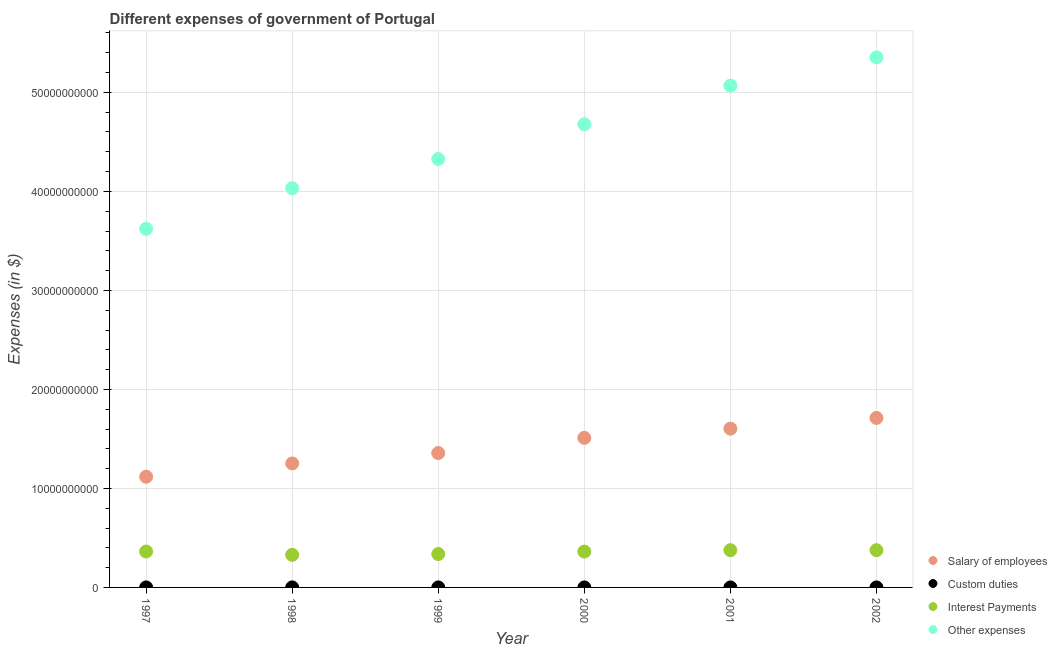What is the amount spent on other expenses in 2001?
Ensure brevity in your answer.  5.07e+1. Across all years, what is the maximum amount spent on salary of employees?
Your answer should be very brief. 1.71e+1. Across all years, what is the minimum amount spent on other expenses?
Make the answer very short. 3.62e+1. In which year was the amount spent on other expenses maximum?
Your answer should be very brief. 2002. In which year was the amount spent on interest payments minimum?
Offer a very short reply. 1998. What is the total amount spent on interest payments in the graph?
Provide a succinct answer. 2.14e+1. What is the difference between the amount spent on custom duties in 1997 and that in 2000?
Keep it short and to the point. 9.00e+05. What is the difference between the amount spent on other expenses in 1997 and the amount spent on custom duties in 1999?
Your answer should be very brief. 3.62e+1. What is the average amount spent on salary of employees per year?
Your answer should be very brief. 1.43e+1. In the year 2002, what is the difference between the amount spent on salary of employees and amount spent on interest payments?
Provide a succinct answer. 1.34e+1. What is the ratio of the amount spent on other expenses in 1998 to that in 2001?
Provide a succinct answer. 0.8. Is the amount spent on custom duties in 1997 less than that in 2001?
Provide a short and direct response. No. Is the difference between the amount spent on other expenses in 2001 and 2002 greater than the difference between the amount spent on interest payments in 2001 and 2002?
Your answer should be compact. No. What is the difference between the highest and the second highest amount spent on interest payments?
Your answer should be compact. 1.30e+06. What is the difference between the highest and the lowest amount spent on custom duties?
Give a very brief answer. 1.87e+06. Is the sum of the amount spent on custom duties in 1997 and 2002 greater than the maximum amount spent on interest payments across all years?
Provide a succinct answer. No. Is it the case that in every year, the sum of the amount spent on salary of employees and amount spent on custom duties is greater than the amount spent on interest payments?
Offer a terse response. Yes. Is the amount spent on salary of employees strictly less than the amount spent on custom duties over the years?
Give a very brief answer. No. How many dotlines are there?
Your answer should be very brief. 4. How many years are there in the graph?
Make the answer very short. 6. Are the values on the major ticks of Y-axis written in scientific E-notation?
Ensure brevity in your answer.  No. Where does the legend appear in the graph?
Give a very brief answer. Bottom right. How many legend labels are there?
Your answer should be compact. 4. What is the title of the graph?
Make the answer very short. Different expenses of government of Portugal. Does "Mammal species" appear as one of the legend labels in the graph?
Keep it short and to the point. No. What is the label or title of the Y-axis?
Keep it short and to the point. Expenses (in $). What is the Expenses (in $) in Salary of employees in 1997?
Give a very brief answer. 1.12e+1. What is the Expenses (in $) in Custom duties in 1997?
Make the answer very short. 1.55e+06. What is the Expenses (in $) in Interest Payments in 1997?
Make the answer very short. 3.63e+09. What is the Expenses (in $) of Other expenses in 1997?
Provide a succinct answer. 3.62e+1. What is the Expenses (in $) in Salary of employees in 1998?
Make the answer very short. 1.25e+1. What is the Expenses (in $) of Custom duties in 1998?
Your answer should be compact. 2.33e+06. What is the Expenses (in $) of Interest Payments in 1998?
Your response must be concise. 3.29e+09. What is the Expenses (in $) of Other expenses in 1998?
Your answer should be very brief. 4.03e+1. What is the Expenses (in $) of Salary of employees in 1999?
Offer a terse response. 1.36e+1. What is the Expenses (in $) in Custom duties in 1999?
Keep it short and to the point. 5.30e+05. What is the Expenses (in $) of Interest Payments in 1999?
Ensure brevity in your answer.  3.37e+09. What is the Expenses (in $) of Other expenses in 1999?
Ensure brevity in your answer.  4.33e+1. What is the Expenses (in $) in Salary of employees in 2000?
Your answer should be compact. 1.51e+1. What is the Expenses (in $) in Custom duties in 2000?
Offer a very short reply. 6.50e+05. What is the Expenses (in $) of Interest Payments in 2000?
Provide a succinct answer. 3.62e+09. What is the Expenses (in $) of Other expenses in 2000?
Ensure brevity in your answer.  4.68e+1. What is the Expenses (in $) of Salary of employees in 2001?
Ensure brevity in your answer.  1.60e+1. What is the Expenses (in $) in Custom duties in 2001?
Provide a succinct answer. 4.60e+05. What is the Expenses (in $) of Interest Payments in 2001?
Your answer should be very brief. 3.76e+09. What is the Expenses (in $) in Other expenses in 2001?
Keep it short and to the point. 5.07e+1. What is the Expenses (in $) in Salary of employees in 2002?
Your answer should be compact. 1.71e+1. What is the Expenses (in $) in Custom duties in 2002?
Make the answer very short. 5.10e+05. What is the Expenses (in $) in Interest Payments in 2002?
Your answer should be very brief. 3.76e+09. What is the Expenses (in $) of Other expenses in 2002?
Give a very brief answer. 5.35e+1. Across all years, what is the maximum Expenses (in $) in Salary of employees?
Your answer should be very brief. 1.71e+1. Across all years, what is the maximum Expenses (in $) in Custom duties?
Offer a very short reply. 2.33e+06. Across all years, what is the maximum Expenses (in $) in Interest Payments?
Offer a very short reply. 3.76e+09. Across all years, what is the maximum Expenses (in $) of Other expenses?
Provide a short and direct response. 5.35e+1. Across all years, what is the minimum Expenses (in $) of Salary of employees?
Give a very brief answer. 1.12e+1. Across all years, what is the minimum Expenses (in $) of Interest Payments?
Give a very brief answer. 3.29e+09. Across all years, what is the minimum Expenses (in $) in Other expenses?
Your answer should be very brief. 3.62e+1. What is the total Expenses (in $) of Salary of employees in the graph?
Your answer should be compact. 8.55e+1. What is the total Expenses (in $) of Custom duties in the graph?
Provide a short and direct response. 6.03e+06. What is the total Expenses (in $) in Interest Payments in the graph?
Your response must be concise. 2.14e+1. What is the total Expenses (in $) of Other expenses in the graph?
Your response must be concise. 2.71e+11. What is the difference between the Expenses (in $) in Salary of employees in 1997 and that in 1998?
Give a very brief answer. -1.34e+09. What is the difference between the Expenses (in $) of Custom duties in 1997 and that in 1998?
Provide a succinct answer. -7.80e+05. What is the difference between the Expenses (in $) in Interest Payments in 1997 and that in 1998?
Offer a very short reply. 3.37e+08. What is the difference between the Expenses (in $) of Other expenses in 1997 and that in 1998?
Keep it short and to the point. -4.10e+09. What is the difference between the Expenses (in $) of Salary of employees in 1997 and that in 1999?
Your answer should be very brief. -2.39e+09. What is the difference between the Expenses (in $) in Custom duties in 1997 and that in 1999?
Make the answer very short. 1.02e+06. What is the difference between the Expenses (in $) of Interest Payments in 1997 and that in 1999?
Offer a terse response. 2.57e+08. What is the difference between the Expenses (in $) in Other expenses in 1997 and that in 1999?
Keep it short and to the point. -7.06e+09. What is the difference between the Expenses (in $) in Salary of employees in 1997 and that in 2000?
Ensure brevity in your answer.  -3.92e+09. What is the difference between the Expenses (in $) of Custom duties in 1997 and that in 2000?
Your response must be concise. 9.00e+05. What is the difference between the Expenses (in $) in Interest Payments in 1997 and that in 2000?
Ensure brevity in your answer.  8.51e+06. What is the difference between the Expenses (in $) of Other expenses in 1997 and that in 2000?
Provide a succinct answer. -1.06e+1. What is the difference between the Expenses (in $) of Salary of employees in 1997 and that in 2001?
Provide a short and direct response. -4.86e+09. What is the difference between the Expenses (in $) in Custom duties in 1997 and that in 2001?
Keep it short and to the point. 1.09e+06. What is the difference between the Expenses (in $) in Interest Payments in 1997 and that in 2001?
Provide a short and direct response. -1.34e+08. What is the difference between the Expenses (in $) in Other expenses in 1997 and that in 2001?
Give a very brief answer. -1.45e+1. What is the difference between the Expenses (in $) in Salary of employees in 1997 and that in 2002?
Give a very brief answer. -5.94e+09. What is the difference between the Expenses (in $) in Custom duties in 1997 and that in 2002?
Give a very brief answer. 1.04e+06. What is the difference between the Expenses (in $) in Interest Payments in 1997 and that in 2002?
Provide a succinct answer. -1.35e+08. What is the difference between the Expenses (in $) of Other expenses in 1997 and that in 2002?
Provide a succinct answer. -1.73e+1. What is the difference between the Expenses (in $) in Salary of employees in 1998 and that in 1999?
Offer a terse response. -1.05e+09. What is the difference between the Expenses (in $) in Custom duties in 1998 and that in 1999?
Provide a short and direct response. 1.80e+06. What is the difference between the Expenses (in $) in Interest Payments in 1998 and that in 1999?
Your response must be concise. -7.99e+07. What is the difference between the Expenses (in $) in Other expenses in 1998 and that in 1999?
Offer a very short reply. -2.96e+09. What is the difference between the Expenses (in $) in Salary of employees in 1998 and that in 2000?
Your response must be concise. -2.59e+09. What is the difference between the Expenses (in $) of Custom duties in 1998 and that in 2000?
Ensure brevity in your answer.  1.68e+06. What is the difference between the Expenses (in $) in Interest Payments in 1998 and that in 2000?
Provide a succinct answer. -3.28e+08. What is the difference between the Expenses (in $) of Other expenses in 1998 and that in 2000?
Provide a short and direct response. -6.46e+09. What is the difference between the Expenses (in $) of Salary of employees in 1998 and that in 2001?
Offer a very short reply. -3.52e+09. What is the difference between the Expenses (in $) in Custom duties in 1998 and that in 2001?
Your answer should be very brief. 1.87e+06. What is the difference between the Expenses (in $) of Interest Payments in 1998 and that in 2001?
Your response must be concise. -4.71e+08. What is the difference between the Expenses (in $) of Other expenses in 1998 and that in 2001?
Provide a succinct answer. -1.04e+1. What is the difference between the Expenses (in $) of Salary of employees in 1998 and that in 2002?
Offer a terse response. -4.60e+09. What is the difference between the Expenses (in $) in Custom duties in 1998 and that in 2002?
Ensure brevity in your answer.  1.82e+06. What is the difference between the Expenses (in $) of Interest Payments in 1998 and that in 2002?
Your answer should be compact. -4.72e+08. What is the difference between the Expenses (in $) of Other expenses in 1998 and that in 2002?
Offer a terse response. -1.32e+1. What is the difference between the Expenses (in $) in Salary of employees in 1999 and that in 2000?
Provide a succinct answer. -1.53e+09. What is the difference between the Expenses (in $) in Interest Payments in 1999 and that in 2000?
Ensure brevity in your answer.  -2.49e+08. What is the difference between the Expenses (in $) of Other expenses in 1999 and that in 2000?
Provide a short and direct response. -3.51e+09. What is the difference between the Expenses (in $) in Salary of employees in 1999 and that in 2001?
Your answer should be compact. -2.47e+09. What is the difference between the Expenses (in $) in Custom duties in 1999 and that in 2001?
Your answer should be compact. 7.00e+04. What is the difference between the Expenses (in $) of Interest Payments in 1999 and that in 2001?
Give a very brief answer. -3.91e+08. What is the difference between the Expenses (in $) in Other expenses in 1999 and that in 2001?
Give a very brief answer. -7.41e+09. What is the difference between the Expenses (in $) in Salary of employees in 1999 and that in 2002?
Offer a terse response. -3.54e+09. What is the difference between the Expenses (in $) of Custom duties in 1999 and that in 2002?
Keep it short and to the point. 2.00e+04. What is the difference between the Expenses (in $) of Interest Payments in 1999 and that in 2002?
Provide a short and direct response. -3.92e+08. What is the difference between the Expenses (in $) of Other expenses in 1999 and that in 2002?
Offer a very short reply. -1.03e+1. What is the difference between the Expenses (in $) in Salary of employees in 2000 and that in 2001?
Keep it short and to the point. -9.32e+08. What is the difference between the Expenses (in $) in Interest Payments in 2000 and that in 2001?
Your response must be concise. -1.42e+08. What is the difference between the Expenses (in $) in Other expenses in 2000 and that in 2001?
Your response must be concise. -3.90e+09. What is the difference between the Expenses (in $) in Salary of employees in 2000 and that in 2002?
Offer a terse response. -2.01e+09. What is the difference between the Expenses (in $) in Custom duties in 2000 and that in 2002?
Offer a very short reply. 1.40e+05. What is the difference between the Expenses (in $) in Interest Payments in 2000 and that in 2002?
Give a very brief answer. -1.43e+08. What is the difference between the Expenses (in $) of Other expenses in 2000 and that in 2002?
Offer a very short reply. -6.76e+09. What is the difference between the Expenses (in $) in Salary of employees in 2001 and that in 2002?
Keep it short and to the point. -1.08e+09. What is the difference between the Expenses (in $) in Custom duties in 2001 and that in 2002?
Offer a terse response. -5.00e+04. What is the difference between the Expenses (in $) of Interest Payments in 2001 and that in 2002?
Offer a very short reply. -1.30e+06. What is the difference between the Expenses (in $) of Other expenses in 2001 and that in 2002?
Ensure brevity in your answer.  -2.86e+09. What is the difference between the Expenses (in $) of Salary of employees in 1997 and the Expenses (in $) of Custom duties in 1998?
Keep it short and to the point. 1.12e+1. What is the difference between the Expenses (in $) in Salary of employees in 1997 and the Expenses (in $) in Interest Payments in 1998?
Make the answer very short. 7.89e+09. What is the difference between the Expenses (in $) of Salary of employees in 1997 and the Expenses (in $) of Other expenses in 1998?
Your answer should be very brief. -2.91e+1. What is the difference between the Expenses (in $) in Custom duties in 1997 and the Expenses (in $) in Interest Payments in 1998?
Ensure brevity in your answer.  -3.29e+09. What is the difference between the Expenses (in $) of Custom duties in 1997 and the Expenses (in $) of Other expenses in 1998?
Make the answer very short. -4.03e+1. What is the difference between the Expenses (in $) of Interest Payments in 1997 and the Expenses (in $) of Other expenses in 1998?
Make the answer very short. -3.67e+1. What is the difference between the Expenses (in $) of Salary of employees in 1997 and the Expenses (in $) of Custom duties in 1999?
Offer a very short reply. 1.12e+1. What is the difference between the Expenses (in $) in Salary of employees in 1997 and the Expenses (in $) in Interest Payments in 1999?
Make the answer very short. 7.81e+09. What is the difference between the Expenses (in $) of Salary of employees in 1997 and the Expenses (in $) of Other expenses in 1999?
Your answer should be compact. -3.21e+1. What is the difference between the Expenses (in $) of Custom duties in 1997 and the Expenses (in $) of Interest Payments in 1999?
Ensure brevity in your answer.  -3.37e+09. What is the difference between the Expenses (in $) in Custom duties in 1997 and the Expenses (in $) in Other expenses in 1999?
Your answer should be very brief. -4.33e+1. What is the difference between the Expenses (in $) in Interest Payments in 1997 and the Expenses (in $) in Other expenses in 1999?
Offer a very short reply. -3.96e+1. What is the difference between the Expenses (in $) in Salary of employees in 1997 and the Expenses (in $) in Custom duties in 2000?
Offer a terse response. 1.12e+1. What is the difference between the Expenses (in $) in Salary of employees in 1997 and the Expenses (in $) in Interest Payments in 2000?
Offer a very short reply. 7.56e+09. What is the difference between the Expenses (in $) of Salary of employees in 1997 and the Expenses (in $) of Other expenses in 2000?
Ensure brevity in your answer.  -3.56e+1. What is the difference between the Expenses (in $) in Custom duties in 1997 and the Expenses (in $) in Interest Payments in 2000?
Make the answer very short. -3.62e+09. What is the difference between the Expenses (in $) in Custom duties in 1997 and the Expenses (in $) in Other expenses in 2000?
Keep it short and to the point. -4.68e+1. What is the difference between the Expenses (in $) in Interest Payments in 1997 and the Expenses (in $) in Other expenses in 2000?
Make the answer very short. -4.32e+1. What is the difference between the Expenses (in $) of Salary of employees in 1997 and the Expenses (in $) of Custom duties in 2001?
Provide a succinct answer. 1.12e+1. What is the difference between the Expenses (in $) of Salary of employees in 1997 and the Expenses (in $) of Interest Payments in 2001?
Your answer should be very brief. 7.42e+09. What is the difference between the Expenses (in $) of Salary of employees in 1997 and the Expenses (in $) of Other expenses in 2001?
Provide a short and direct response. -3.95e+1. What is the difference between the Expenses (in $) of Custom duties in 1997 and the Expenses (in $) of Interest Payments in 2001?
Provide a short and direct response. -3.76e+09. What is the difference between the Expenses (in $) of Custom duties in 1997 and the Expenses (in $) of Other expenses in 2001?
Make the answer very short. -5.07e+1. What is the difference between the Expenses (in $) of Interest Payments in 1997 and the Expenses (in $) of Other expenses in 2001?
Provide a short and direct response. -4.71e+1. What is the difference between the Expenses (in $) in Salary of employees in 1997 and the Expenses (in $) in Custom duties in 2002?
Give a very brief answer. 1.12e+1. What is the difference between the Expenses (in $) of Salary of employees in 1997 and the Expenses (in $) of Interest Payments in 2002?
Your response must be concise. 7.42e+09. What is the difference between the Expenses (in $) in Salary of employees in 1997 and the Expenses (in $) in Other expenses in 2002?
Offer a terse response. -4.24e+1. What is the difference between the Expenses (in $) in Custom duties in 1997 and the Expenses (in $) in Interest Payments in 2002?
Offer a very short reply. -3.76e+09. What is the difference between the Expenses (in $) of Custom duties in 1997 and the Expenses (in $) of Other expenses in 2002?
Your answer should be compact. -5.35e+1. What is the difference between the Expenses (in $) of Interest Payments in 1997 and the Expenses (in $) of Other expenses in 2002?
Make the answer very short. -4.99e+1. What is the difference between the Expenses (in $) of Salary of employees in 1998 and the Expenses (in $) of Custom duties in 1999?
Offer a terse response. 1.25e+1. What is the difference between the Expenses (in $) of Salary of employees in 1998 and the Expenses (in $) of Interest Payments in 1999?
Give a very brief answer. 9.15e+09. What is the difference between the Expenses (in $) in Salary of employees in 1998 and the Expenses (in $) in Other expenses in 1999?
Your response must be concise. -3.08e+1. What is the difference between the Expenses (in $) of Custom duties in 1998 and the Expenses (in $) of Interest Payments in 1999?
Provide a short and direct response. -3.37e+09. What is the difference between the Expenses (in $) of Custom duties in 1998 and the Expenses (in $) of Other expenses in 1999?
Make the answer very short. -4.33e+1. What is the difference between the Expenses (in $) of Interest Payments in 1998 and the Expenses (in $) of Other expenses in 1999?
Provide a succinct answer. -4.00e+1. What is the difference between the Expenses (in $) of Salary of employees in 1998 and the Expenses (in $) of Custom duties in 2000?
Your answer should be compact. 1.25e+1. What is the difference between the Expenses (in $) in Salary of employees in 1998 and the Expenses (in $) in Interest Payments in 2000?
Keep it short and to the point. 8.90e+09. What is the difference between the Expenses (in $) of Salary of employees in 1998 and the Expenses (in $) of Other expenses in 2000?
Keep it short and to the point. -3.43e+1. What is the difference between the Expenses (in $) of Custom duties in 1998 and the Expenses (in $) of Interest Payments in 2000?
Provide a short and direct response. -3.62e+09. What is the difference between the Expenses (in $) of Custom duties in 1998 and the Expenses (in $) of Other expenses in 2000?
Offer a terse response. -4.68e+1. What is the difference between the Expenses (in $) in Interest Payments in 1998 and the Expenses (in $) in Other expenses in 2000?
Your answer should be very brief. -4.35e+1. What is the difference between the Expenses (in $) of Salary of employees in 1998 and the Expenses (in $) of Custom duties in 2001?
Ensure brevity in your answer.  1.25e+1. What is the difference between the Expenses (in $) in Salary of employees in 1998 and the Expenses (in $) in Interest Payments in 2001?
Offer a very short reply. 8.76e+09. What is the difference between the Expenses (in $) in Salary of employees in 1998 and the Expenses (in $) in Other expenses in 2001?
Offer a very short reply. -3.82e+1. What is the difference between the Expenses (in $) of Custom duties in 1998 and the Expenses (in $) of Interest Payments in 2001?
Offer a terse response. -3.76e+09. What is the difference between the Expenses (in $) in Custom duties in 1998 and the Expenses (in $) in Other expenses in 2001?
Make the answer very short. -5.07e+1. What is the difference between the Expenses (in $) in Interest Payments in 1998 and the Expenses (in $) in Other expenses in 2001?
Keep it short and to the point. -4.74e+1. What is the difference between the Expenses (in $) of Salary of employees in 1998 and the Expenses (in $) of Custom duties in 2002?
Ensure brevity in your answer.  1.25e+1. What is the difference between the Expenses (in $) of Salary of employees in 1998 and the Expenses (in $) of Interest Payments in 2002?
Your response must be concise. 8.76e+09. What is the difference between the Expenses (in $) of Salary of employees in 1998 and the Expenses (in $) of Other expenses in 2002?
Offer a very short reply. -4.10e+1. What is the difference between the Expenses (in $) of Custom duties in 1998 and the Expenses (in $) of Interest Payments in 2002?
Make the answer very short. -3.76e+09. What is the difference between the Expenses (in $) of Custom duties in 1998 and the Expenses (in $) of Other expenses in 2002?
Provide a short and direct response. -5.35e+1. What is the difference between the Expenses (in $) in Interest Payments in 1998 and the Expenses (in $) in Other expenses in 2002?
Your response must be concise. -5.02e+1. What is the difference between the Expenses (in $) in Salary of employees in 1999 and the Expenses (in $) in Custom duties in 2000?
Provide a succinct answer. 1.36e+1. What is the difference between the Expenses (in $) of Salary of employees in 1999 and the Expenses (in $) of Interest Payments in 2000?
Offer a very short reply. 9.95e+09. What is the difference between the Expenses (in $) in Salary of employees in 1999 and the Expenses (in $) in Other expenses in 2000?
Ensure brevity in your answer.  -3.32e+1. What is the difference between the Expenses (in $) in Custom duties in 1999 and the Expenses (in $) in Interest Payments in 2000?
Give a very brief answer. -3.62e+09. What is the difference between the Expenses (in $) in Custom duties in 1999 and the Expenses (in $) in Other expenses in 2000?
Provide a succinct answer. -4.68e+1. What is the difference between the Expenses (in $) in Interest Payments in 1999 and the Expenses (in $) in Other expenses in 2000?
Your answer should be very brief. -4.34e+1. What is the difference between the Expenses (in $) in Salary of employees in 1999 and the Expenses (in $) in Custom duties in 2001?
Your answer should be compact. 1.36e+1. What is the difference between the Expenses (in $) in Salary of employees in 1999 and the Expenses (in $) in Interest Payments in 2001?
Give a very brief answer. 9.81e+09. What is the difference between the Expenses (in $) in Salary of employees in 1999 and the Expenses (in $) in Other expenses in 2001?
Offer a terse response. -3.71e+1. What is the difference between the Expenses (in $) in Custom duties in 1999 and the Expenses (in $) in Interest Payments in 2001?
Offer a terse response. -3.76e+09. What is the difference between the Expenses (in $) of Custom duties in 1999 and the Expenses (in $) of Other expenses in 2001?
Offer a terse response. -5.07e+1. What is the difference between the Expenses (in $) in Interest Payments in 1999 and the Expenses (in $) in Other expenses in 2001?
Provide a succinct answer. -4.73e+1. What is the difference between the Expenses (in $) in Salary of employees in 1999 and the Expenses (in $) in Custom duties in 2002?
Make the answer very short. 1.36e+1. What is the difference between the Expenses (in $) of Salary of employees in 1999 and the Expenses (in $) of Interest Payments in 2002?
Make the answer very short. 9.81e+09. What is the difference between the Expenses (in $) of Salary of employees in 1999 and the Expenses (in $) of Other expenses in 2002?
Your answer should be very brief. -4.00e+1. What is the difference between the Expenses (in $) of Custom duties in 1999 and the Expenses (in $) of Interest Payments in 2002?
Give a very brief answer. -3.76e+09. What is the difference between the Expenses (in $) of Custom duties in 1999 and the Expenses (in $) of Other expenses in 2002?
Offer a very short reply. -5.35e+1. What is the difference between the Expenses (in $) of Interest Payments in 1999 and the Expenses (in $) of Other expenses in 2002?
Offer a very short reply. -5.02e+1. What is the difference between the Expenses (in $) of Salary of employees in 2000 and the Expenses (in $) of Custom duties in 2001?
Your answer should be very brief. 1.51e+1. What is the difference between the Expenses (in $) in Salary of employees in 2000 and the Expenses (in $) in Interest Payments in 2001?
Keep it short and to the point. 1.13e+1. What is the difference between the Expenses (in $) in Salary of employees in 2000 and the Expenses (in $) in Other expenses in 2001?
Provide a succinct answer. -3.56e+1. What is the difference between the Expenses (in $) in Custom duties in 2000 and the Expenses (in $) in Interest Payments in 2001?
Your response must be concise. -3.76e+09. What is the difference between the Expenses (in $) in Custom duties in 2000 and the Expenses (in $) in Other expenses in 2001?
Keep it short and to the point. -5.07e+1. What is the difference between the Expenses (in $) in Interest Payments in 2000 and the Expenses (in $) in Other expenses in 2001?
Offer a very short reply. -4.71e+1. What is the difference between the Expenses (in $) in Salary of employees in 2000 and the Expenses (in $) in Custom duties in 2002?
Your response must be concise. 1.51e+1. What is the difference between the Expenses (in $) in Salary of employees in 2000 and the Expenses (in $) in Interest Payments in 2002?
Your answer should be very brief. 1.13e+1. What is the difference between the Expenses (in $) in Salary of employees in 2000 and the Expenses (in $) in Other expenses in 2002?
Offer a terse response. -3.84e+1. What is the difference between the Expenses (in $) of Custom duties in 2000 and the Expenses (in $) of Interest Payments in 2002?
Ensure brevity in your answer.  -3.76e+09. What is the difference between the Expenses (in $) of Custom duties in 2000 and the Expenses (in $) of Other expenses in 2002?
Your response must be concise. -5.35e+1. What is the difference between the Expenses (in $) in Interest Payments in 2000 and the Expenses (in $) in Other expenses in 2002?
Your answer should be very brief. -4.99e+1. What is the difference between the Expenses (in $) in Salary of employees in 2001 and the Expenses (in $) in Custom duties in 2002?
Offer a terse response. 1.60e+1. What is the difference between the Expenses (in $) in Salary of employees in 2001 and the Expenses (in $) in Interest Payments in 2002?
Ensure brevity in your answer.  1.23e+1. What is the difference between the Expenses (in $) of Salary of employees in 2001 and the Expenses (in $) of Other expenses in 2002?
Ensure brevity in your answer.  -3.75e+1. What is the difference between the Expenses (in $) in Custom duties in 2001 and the Expenses (in $) in Interest Payments in 2002?
Ensure brevity in your answer.  -3.76e+09. What is the difference between the Expenses (in $) in Custom duties in 2001 and the Expenses (in $) in Other expenses in 2002?
Your answer should be very brief. -5.35e+1. What is the difference between the Expenses (in $) in Interest Payments in 2001 and the Expenses (in $) in Other expenses in 2002?
Provide a short and direct response. -4.98e+1. What is the average Expenses (in $) in Salary of employees per year?
Provide a succinct answer. 1.43e+1. What is the average Expenses (in $) in Custom duties per year?
Ensure brevity in your answer.  1.00e+06. What is the average Expenses (in $) of Interest Payments per year?
Offer a terse response. 3.57e+09. What is the average Expenses (in $) in Other expenses per year?
Your answer should be compact. 4.51e+1. In the year 1997, what is the difference between the Expenses (in $) of Salary of employees and Expenses (in $) of Custom duties?
Offer a very short reply. 1.12e+1. In the year 1997, what is the difference between the Expenses (in $) of Salary of employees and Expenses (in $) of Interest Payments?
Your response must be concise. 7.55e+09. In the year 1997, what is the difference between the Expenses (in $) of Salary of employees and Expenses (in $) of Other expenses?
Make the answer very short. -2.50e+1. In the year 1997, what is the difference between the Expenses (in $) of Custom duties and Expenses (in $) of Interest Payments?
Provide a short and direct response. -3.63e+09. In the year 1997, what is the difference between the Expenses (in $) in Custom duties and Expenses (in $) in Other expenses?
Provide a succinct answer. -3.62e+1. In the year 1997, what is the difference between the Expenses (in $) in Interest Payments and Expenses (in $) in Other expenses?
Offer a terse response. -3.26e+1. In the year 1998, what is the difference between the Expenses (in $) in Salary of employees and Expenses (in $) in Custom duties?
Offer a terse response. 1.25e+1. In the year 1998, what is the difference between the Expenses (in $) of Salary of employees and Expenses (in $) of Interest Payments?
Your answer should be very brief. 9.23e+09. In the year 1998, what is the difference between the Expenses (in $) of Salary of employees and Expenses (in $) of Other expenses?
Your answer should be compact. -2.78e+1. In the year 1998, what is the difference between the Expenses (in $) in Custom duties and Expenses (in $) in Interest Payments?
Keep it short and to the point. -3.29e+09. In the year 1998, what is the difference between the Expenses (in $) of Custom duties and Expenses (in $) of Other expenses?
Keep it short and to the point. -4.03e+1. In the year 1998, what is the difference between the Expenses (in $) in Interest Payments and Expenses (in $) in Other expenses?
Offer a terse response. -3.70e+1. In the year 1999, what is the difference between the Expenses (in $) of Salary of employees and Expenses (in $) of Custom duties?
Your response must be concise. 1.36e+1. In the year 1999, what is the difference between the Expenses (in $) in Salary of employees and Expenses (in $) in Interest Payments?
Provide a short and direct response. 1.02e+1. In the year 1999, what is the difference between the Expenses (in $) of Salary of employees and Expenses (in $) of Other expenses?
Ensure brevity in your answer.  -2.97e+1. In the year 1999, what is the difference between the Expenses (in $) of Custom duties and Expenses (in $) of Interest Payments?
Provide a succinct answer. -3.37e+09. In the year 1999, what is the difference between the Expenses (in $) in Custom duties and Expenses (in $) in Other expenses?
Provide a succinct answer. -4.33e+1. In the year 1999, what is the difference between the Expenses (in $) in Interest Payments and Expenses (in $) in Other expenses?
Offer a very short reply. -3.99e+1. In the year 2000, what is the difference between the Expenses (in $) in Salary of employees and Expenses (in $) in Custom duties?
Your response must be concise. 1.51e+1. In the year 2000, what is the difference between the Expenses (in $) of Salary of employees and Expenses (in $) of Interest Payments?
Offer a terse response. 1.15e+1. In the year 2000, what is the difference between the Expenses (in $) of Salary of employees and Expenses (in $) of Other expenses?
Offer a terse response. -3.17e+1. In the year 2000, what is the difference between the Expenses (in $) of Custom duties and Expenses (in $) of Interest Payments?
Keep it short and to the point. -3.62e+09. In the year 2000, what is the difference between the Expenses (in $) in Custom duties and Expenses (in $) in Other expenses?
Your response must be concise. -4.68e+1. In the year 2000, what is the difference between the Expenses (in $) of Interest Payments and Expenses (in $) of Other expenses?
Give a very brief answer. -4.32e+1. In the year 2001, what is the difference between the Expenses (in $) in Salary of employees and Expenses (in $) in Custom duties?
Offer a terse response. 1.60e+1. In the year 2001, what is the difference between the Expenses (in $) of Salary of employees and Expenses (in $) of Interest Payments?
Make the answer very short. 1.23e+1. In the year 2001, what is the difference between the Expenses (in $) of Salary of employees and Expenses (in $) of Other expenses?
Your response must be concise. -3.46e+1. In the year 2001, what is the difference between the Expenses (in $) in Custom duties and Expenses (in $) in Interest Payments?
Offer a very short reply. -3.76e+09. In the year 2001, what is the difference between the Expenses (in $) of Custom duties and Expenses (in $) of Other expenses?
Provide a succinct answer. -5.07e+1. In the year 2001, what is the difference between the Expenses (in $) of Interest Payments and Expenses (in $) of Other expenses?
Keep it short and to the point. -4.69e+1. In the year 2002, what is the difference between the Expenses (in $) in Salary of employees and Expenses (in $) in Custom duties?
Your answer should be compact. 1.71e+1. In the year 2002, what is the difference between the Expenses (in $) of Salary of employees and Expenses (in $) of Interest Payments?
Provide a short and direct response. 1.34e+1. In the year 2002, what is the difference between the Expenses (in $) in Salary of employees and Expenses (in $) in Other expenses?
Offer a terse response. -3.64e+1. In the year 2002, what is the difference between the Expenses (in $) in Custom duties and Expenses (in $) in Interest Payments?
Ensure brevity in your answer.  -3.76e+09. In the year 2002, what is the difference between the Expenses (in $) in Custom duties and Expenses (in $) in Other expenses?
Your response must be concise. -5.35e+1. In the year 2002, what is the difference between the Expenses (in $) of Interest Payments and Expenses (in $) of Other expenses?
Offer a terse response. -4.98e+1. What is the ratio of the Expenses (in $) of Salary of employees in 1997 to that in 1998?
Provide a succinct answer. 0.89. What is the ratio of the Expenses (in $) in Custom duties in 1997 to that in 1998?
Provide a short and direct response. 0.67. What is the ratio of the Expenses (in $) in Interest Payments in 1997 to that in 1998?
Provide a short and direct response. 1.1. What is the ratio of the Expenses (in $) of Other expenses in 1997 to that in 1998?
Your answer should be very brief. 0.9. What is the ratio of the Expenses (in $) in Salary of employees in 1997 to that in 1999?
Offer a terse response. 0.82. What is the ratio of the Expenses (in $) of Custom duties in 1997 to that in 1999?
Provide a succinct answer. 2.92. What is the ratio of the Expenses (in $) of Interest Payments in 1997 to that in 1999?
Make the answer very short. 1.08. What is the ratio of the Expenses (in $) in Other expenses in 1997 to that in 1999?
Offer a terse response. 0.84. What is the ratio of the Expenses (in $) in Salary of employees in 1997 to that in 2000?
Provide a short and direct response. 0.74. What is the ratio of the Expenses (in $) of Custom duties in 1997 to that in 2000?
Offer a terse response. 2.38. What is the ratio of the Expenses (in $) of Interest Payments in 1997 to that in 2000?
Keep it short and to the point. 1. What is the ratio of the Expenses (in $) in Other expenses in 1997 to that in 2000?
Your answer should be compact. 0.77. What is the ratio of the Expenses (in $) in Salary of employees in 1997 to that in 2001?
Ensure brevity in your answer.  0.7. What is the ratio of the Expenses (in $) in Custom duties in 1997 to that in 2001?
Make the answer very short. 3.37. What is the ratio of the Expenses (in $) of Interest Payments in 1997 to that in 2001?
Make the answer very short. 0.96. What is the ratio of the Expenses (in $) in Other expenses in 1997 to that in 2001?
Your answer should be very brief. 0.71. What is the ratio of the Expenses (in $) of Salary of employees in 1997 to that in 2002?
Provide a short and direct response. 0.65. What is the ratio of the Expenses (in $) in Custom duties in 1997 to that in 2002?
Your answer should be compact. 3.04. What is the ratio of the Expenses (in $) in Interest Payments in 1997 to that in 2002?
Give a very brief answer. 0.96. What is the ratio of the Expenses (in $) in Other expenses in 1997 to that in 2002?
Your answer should be compact. 0.68. What is the ratio of the Expenses (in $) in Salary of employees in 1998 to that in 1999?
Your answer should be very brief. 0.92. What is the ratio of the Expenses (in $) in Custom duties in 1998 to that in 1999?
Your response must be concise. 4.4. What is the ratio of the Expenses (in $) of Interest Payments in 1998 to that in 1999?
Offer a very short reply. 0.98. What is the ratio of the Expenses (in $) of Other expenses in 1998 to that in 1999?
Keep it short and to the point. 0.93. What is the ratio of the Expenses (in $) in Salary of employees in 1998 to that in 2000?
Your answer should be very brief. 0.83. What is the ratio of the Expenses (in $) of Custom duties in 1998 to that in 2000?
Offer a very short reply. 3.58. What is the ratio of the Expenses (in $) of Interest Payments in 1998 to that in 2000?
Your answer should be compact. 0.91. What is the ratio of the Expenses (in $) of Other expenses in 1998 to that in 2000?
Make the answer very short. 0.86. What is the ratio of the Expenses (in $) of Salary of employees in 1998 to that in 2001?
Your response must be concise. 0.78. What is the ratio of the Expenses (in $) of Custom duties in 1998 to that in 2001?
Your response must be concise. 5.07. What is the ratio of the Expenses (in $) in Interest Payments in 1998 to that in 2001?
Keep it short and to the point. 0.87. What is the ratio of the Expenses (in $) of Other expenses in 1998 to that in 2001?
Your response must be concise. 0.8. What is the ratio of the Expenses (in $) in Salary of employees in 1998 to that in 2002?
Your answer should be very brief. 0.73. What is the ratio of the Expenses (in $) of Custom duties in 1998 to that in 2002?
Keep it short and to the point. 4.57. What is the ratio of the Expenses (in $) of Interest Payments in 1998 to that in 2002?
Offer a terse response. 0.87. What is the ratio of the Expenses (in $) in Other expenses in 1998 to that in 2002?
Your response must be concise. 0.75. What is the ratio of the Expenses (in $) of Salary of employees in 1999 to that in 2000?
Make the answer very short. 0.9. What is the ratio of the Expenses (in $) of Custom duties in 1999 to that in 2000?
Keep it short and to the point. 0.82. What is the ratio of the Expenses (in $) of Interest Payments in 1999 to that in 2000?
Provide a short and direct response. 0.93. What is the ratio of the Expenses (in $) in Other expenses in 1999 to that in 2000?
Your answer should be compact. 0.93. What is the ratio of the Expenses (in $) in Salary of employees in 1999 to that in 2001?
Ensure brevity in your answer.  0.85. What is the ratio of the Expenses (in $) in Custom duties in 1999 to that in 2001?
Offer a very short reply. 1.15. What is the ratio of the Expenses (in $) of Interest Payments in 1999 to that in 2001?
Provide a short and direct response. 0.9. What is the ratio of the Expenses (in $) of Other expenses in 1999 to that in 2001?
Offer a terse response. 0.85. What is the ratio of the Expenses (in $) in Salary of employees in 1999 to that in 2002?
Offer a very short reply. 0.79. What is the ratio of the Expenses (in $) of Custom duties in 1999 to that in 2002?
Provide a short and direct response. 1.04. What is the ratio of the Expenses (in $) in Interest Payments in 1999 to that in 2002?
Offer a very short reply. 0.9. What is the ratio of the Expenses (in $) of Other expenses in 1999 to that in 2002?
Ensure brevity in your answer.  0.81. What is the ratio of the Expenses (in $) in Salary of employees in 2000 to that in 2001?
Offer a very short reply. 0.94. What is the ratio of the Expenses (in $) in Custom duties in 2000 to that in 2001?
Make the answer very short. 1.41. What is the ratio of the Expenses (in $) of Interest Payments in 2000 to that in 2001?
Give a very brief answer. 0.96. What is the ratio of the Expenses (in $) in Other expenses in 2000 to that in 2001?
Offer a very short reply. 0.92. What is the ratio of the Expenses (in $) in Salary of employees in 2000 to that in 2002?
Provide a succinct answer. 0.88. What is the ratio of the Expenses (in $) of Custom duties in 2000 to that in 2002?
Offer a very short reply. 1.27. What is the ratio of the Expenses (in $) in Interest Payments in 2000 to that in 2002?
Your response must be concise. 0.96. What is the ratio of the Expenses (in $) of Other expenses in 2000 to that in 2002?
Offer a terse response. 0.87. What is the ratio of the Expenses (in $) of Salary of employees in 2001 to that in 2002?
Keep it short and to the point. 0.94. What is the ratio of the Expenses (in $) in Custom duties in 2001 to that in 2002?
Keep it short and to the point. 0.9. What is the ratio of the Expenses (in $) of Interest Payments in 2001 to that in 2002?
Give a very brief answer. 1. What is the ratio of the Expenses (in $) in Other expenses in 2001 to that in 2002?
Offer a terse response. 0.95. What is the difference between the highest and the second highest Expenses (in $) of Salary of employees?
Give a very brief answer. 1.08e+09. What is the difference between the highest and the second highest Expenses (in $) of Custom duties?
Offer a very short reply. 7.80e+05. What is the difference between the highest and the second highest Expenses (in $) in Interest Payments?
Keep it short and to the point. 1.30e+06. What is the difference between the highest and the second highest Expenses (in $) of Other expenses?
Ensure brevity in your answer.  2.86e+09. What is the difference between the highest and the lowest Expenses (in $) in Salary of employees?
Provide a short and direct response. 5.94e+09. What is the difference between the highest and the lowest Expenses (in $) of Custom duties?
Your answer should be compact. 1.87e+06. What is the difference between the highest and the lowest Expenses (in $) in Interest Payments?
Give a very brief answer. 4.72e+08. What is the difference between the highest and the lowest Expenses (in $) of Other expenses?
Give a very brief answer. 1.73e+1. 